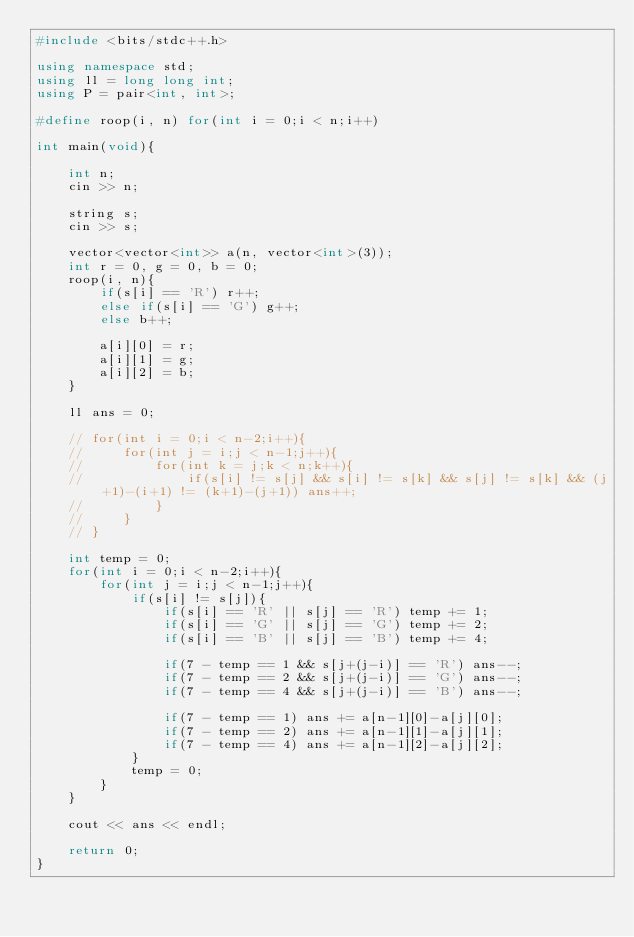<code> <loc_0><loc_0><loc_500><loc_500><_C++_>#include <bits/stdc++.h>

using namespace std;
using ll = long long int;
using P = pair<int, int>;

#define roop(i, n) for(int i = 0;i < n;i++)

int main(void){

    int n;
    cin >> n;

    string s;
    cin >> s;

    vector<vector<int>> a(n, vector<int>(3));
    int r = 0, g = 0, b = 0;
    roop(i, n){
        if(s[i] == 'R') r++;
        else if(s[i] == 'G') g++;
        else b++;

        a[i][0] = r;
        a[i][1] = g;
        a[i][2] = b;
    }

    ll ans = 0;

    // for(int i = 0;i < n-2;i++){
    //     for(int j = i;j < n-1;j++){
    //         for(int k = j;k < n;k++){
    //             if(s[i] != s[j] && s[i] != s[k] && s[j] != s[k] && (j+1)-(i+1) != (k+1)-(j+1)) ans++;
    //         }
    //     }
    // }

    int temp = 0;
    for(int i = 0;i < n-2;i++){
        for(int j = i;j < n-1;j++){
            if(s[i] != s[j]){
                if(s[i] == 'R' || s[j] == 'R') temp += 1;
                if(s[i] == 'G' || s[j] == 'G') temp += 2;
                if(s[i] == 'B' || s[j] == 'B') temp += 4;

                if(7 - temp == 1 && s[j+(j-i)] == 'R') ans--;
                if(7 - temp == 2 && s[j+(j-i)] == 'G') ans--;
                if(7 - temp == 4 && s[j+(j-i)] == 'B') ans--;

                if(7 - temp == 1) ans += a[n-1][0]-a[j][0];
                if(7 - temp == 2) ans += a[n-1][1]-a[j][1];
                if(7 - temp == 4) ans += a[n-1][2]-a[j][2];
            }
            temp = 0;
        }
    }

    cout << ans << endl;

    return 0;
}</code> 